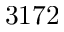<formula> <loc_0><loc_0><loc_500><loc_500>3 1 7 2</formula> 